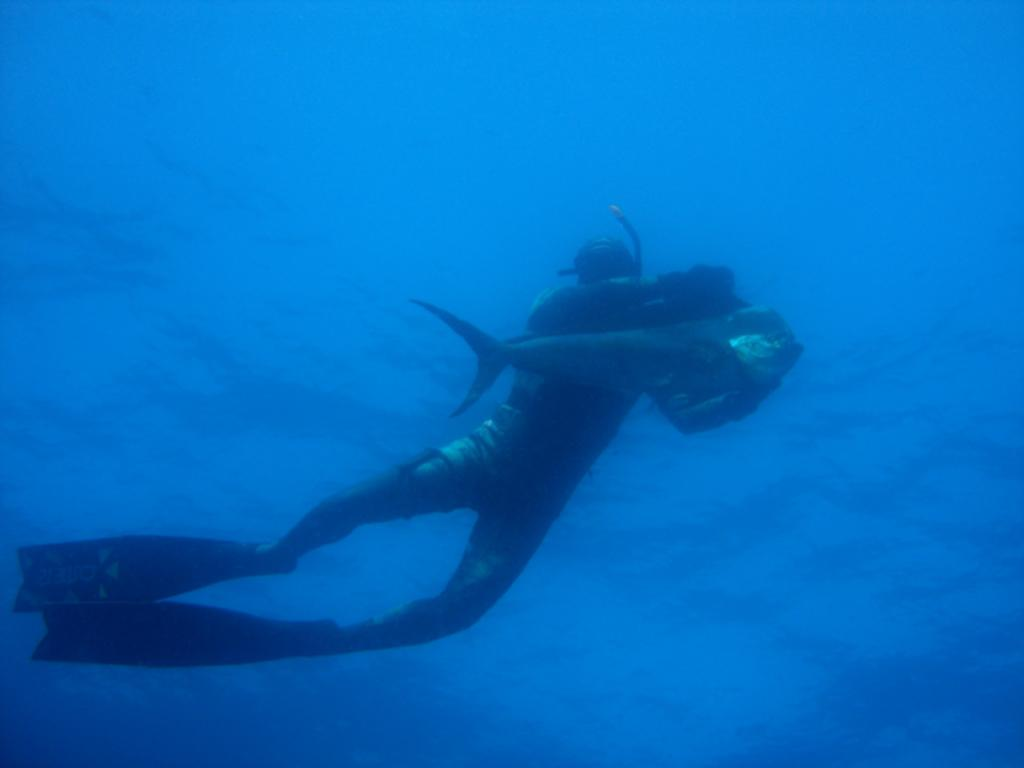What type of environment is shown in the image? The image depicts an underwater environment. What type of animal can be seen in the image? There is a fish in the image. Are there any human elements in the image? Yes, there is a person in the image. What type of rat can be seen interacting with the scarecrow in the image? There is no rat or scarecrow present in the image; it depicts an underwater environment with a fish and a person. 